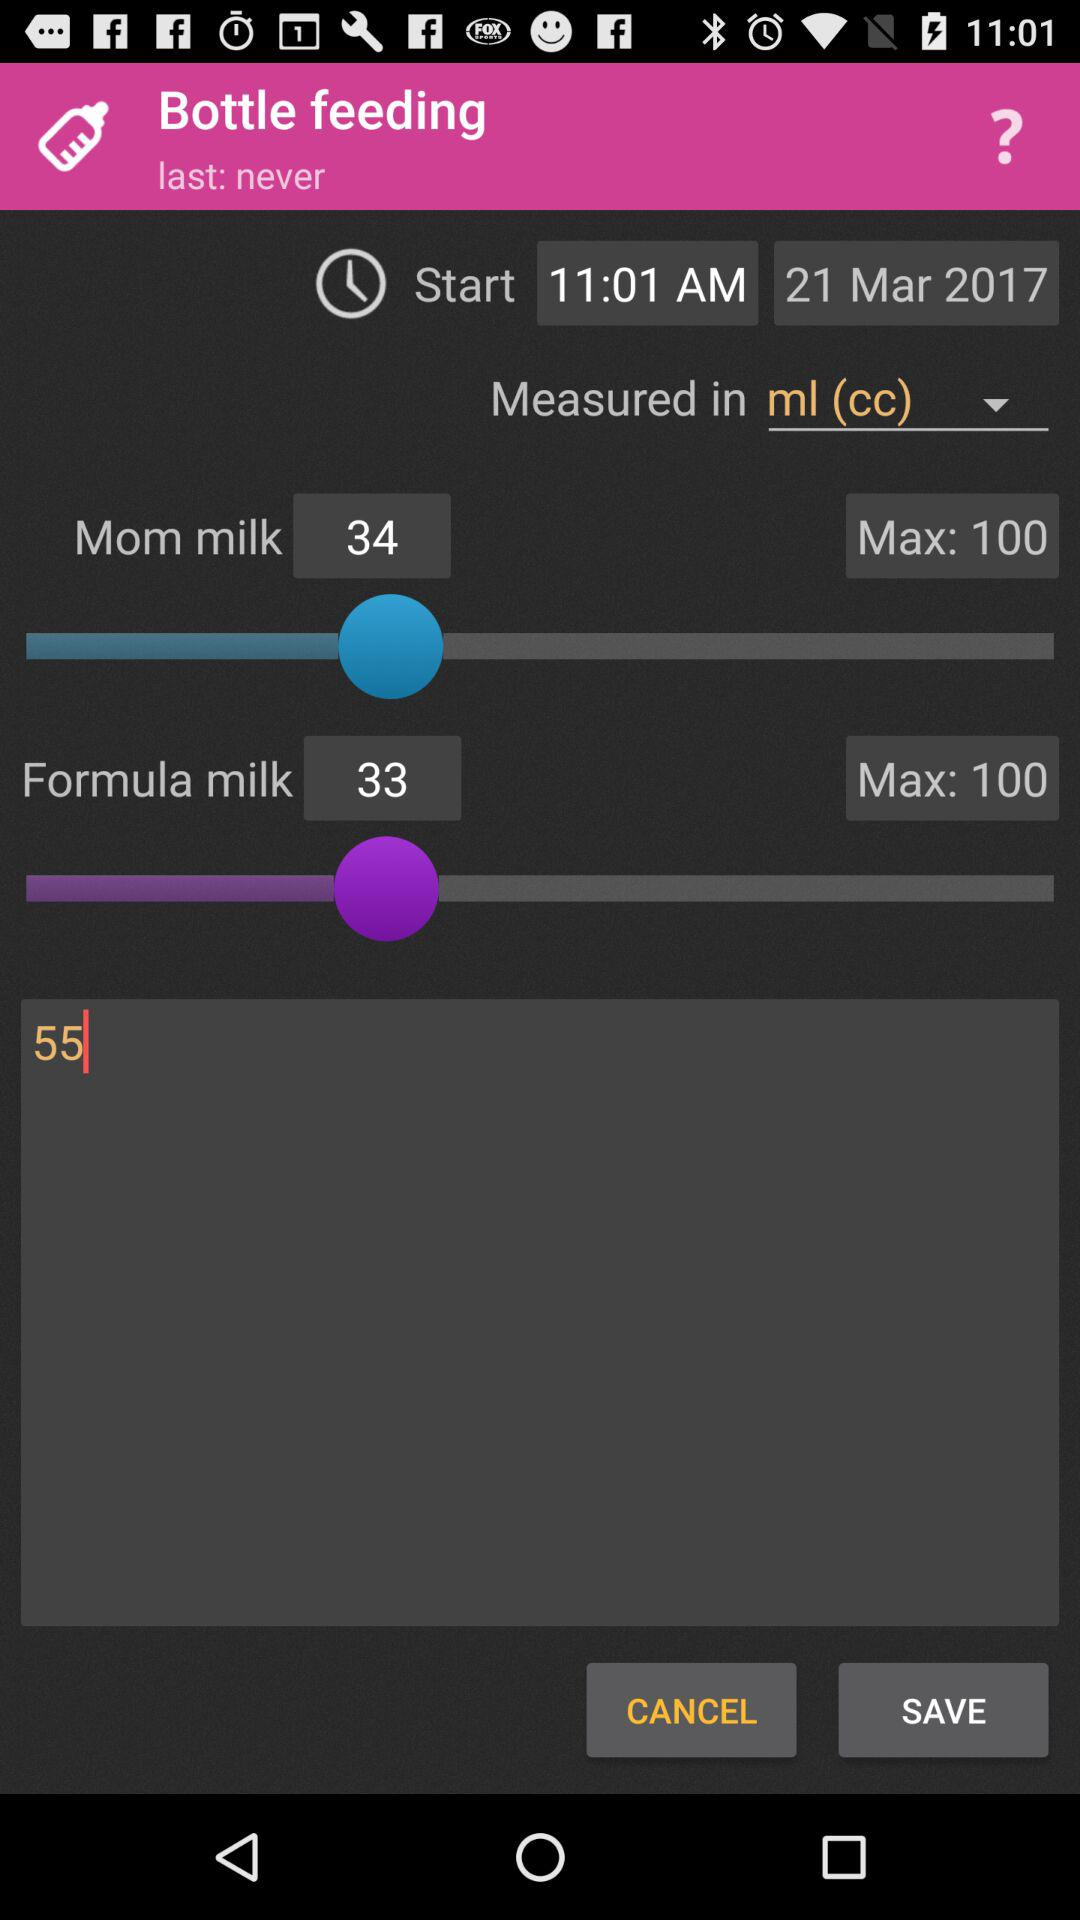What is the total amount of milk given?
Answer the question using a single word or phrase. 67 